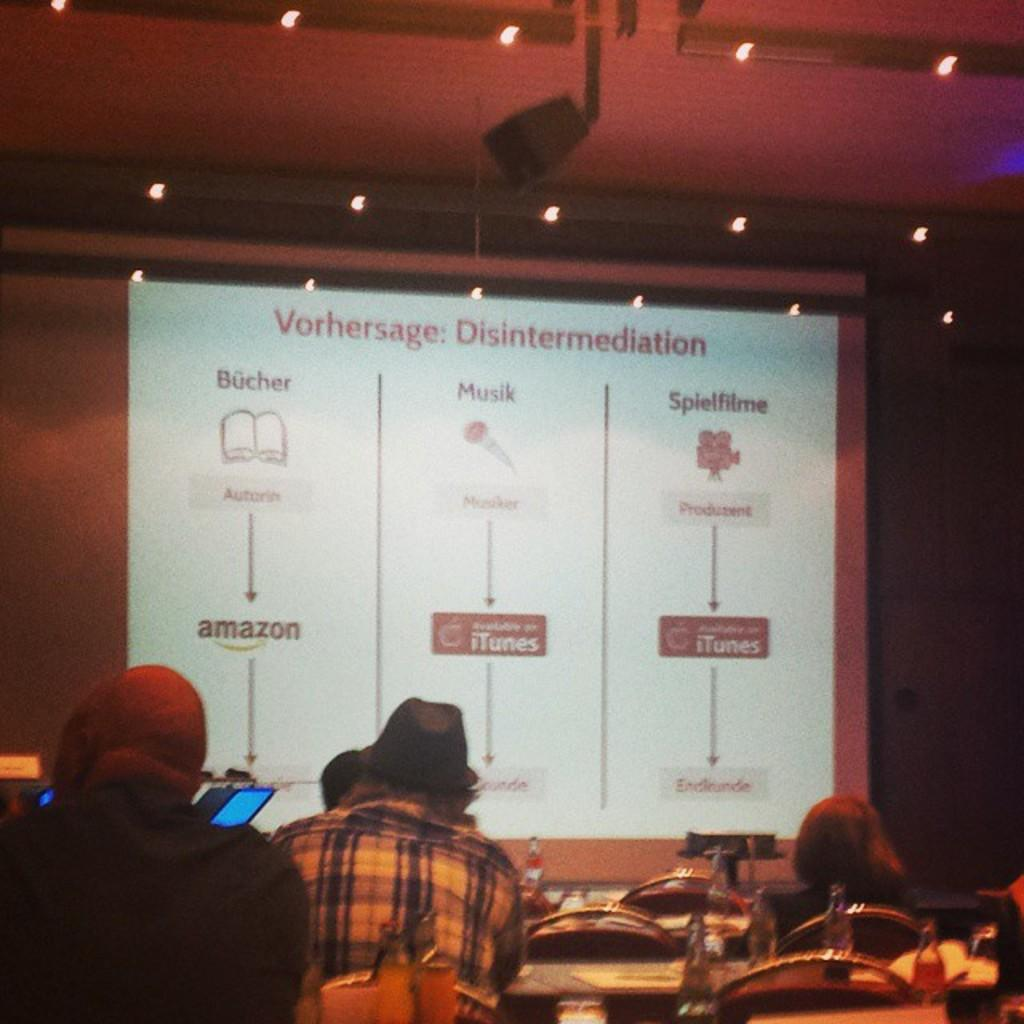What are the people in the image doing? The people in the image are sitting at the bottom. What type of furniture is present in the image? There are tables and chairs in the image. What is the main object in the center of the image? There is a screen in the center of the image. What can be seen at the top of the image? There are lights at the top of the image. How many pages does the woman turn in the image? There is no woman present in the image, and no pages are being turned. 